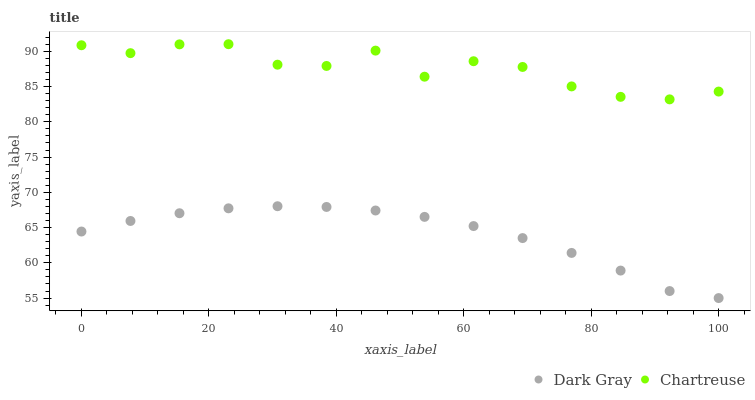Does Dark Gray have the minimum area under the curve?
Answer yes or no. Yes. Does Chartreuse have the maximum area under the curve?
Answer yes or no. Yes. Does Chartreuse have the minimum area under the curve?
Answer yes or no. No. Is Dark Gray the smoothest?
Answer yes or no. Yes. Is Chartreuse the roughest?
Answer yes or no. Yes. Is Chartreuse the smoothest?
Answer yes or no. No. Does Dark Gray have the lowest value?
Answer yes or no. Yes. Does Chartreuse have the lowest value?
Answer yes or no. No. Does Chartreuse have the highest value?
Answer yes or no. Yes. Is Dark Gray less than Chartreuse?
Answer yes or no. Yes. Is Chartreuse greater than Dark Gray?
Answer yes or no. Yes. Does Dark Gray intersect Chartreuse?
Answer yes or no. No. 